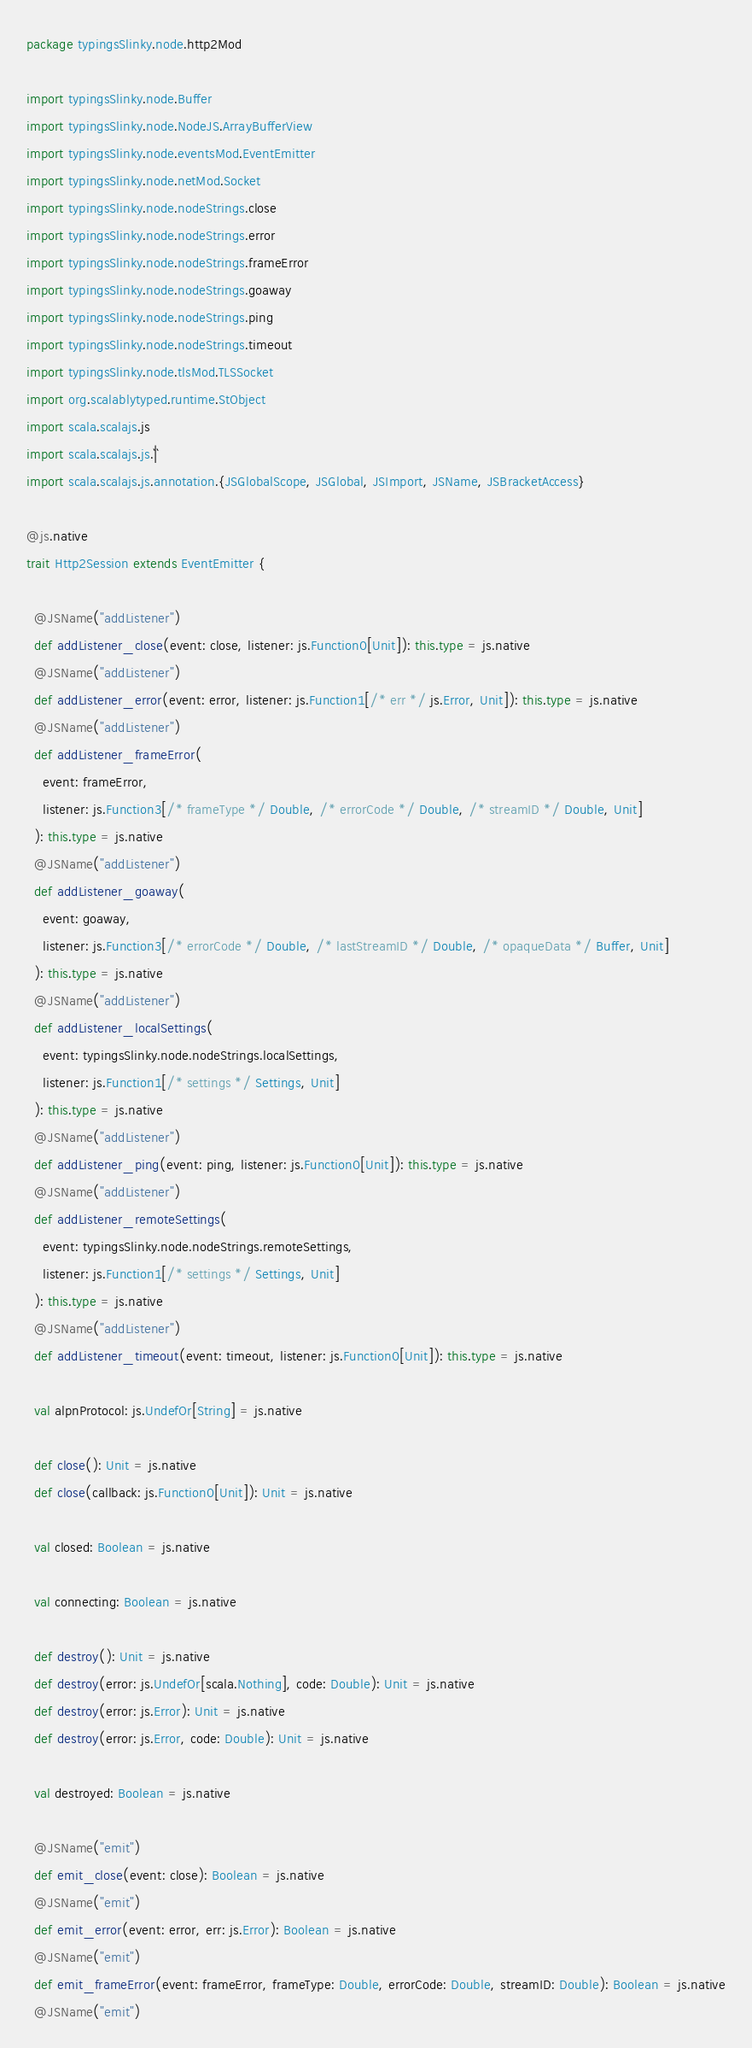Convert code to text. <code><loc_0><loc_0><loc_500><loc_500><_Scala_>package typingsSlinky.node.http2Mod

import typingsSlinky.node.Buffer
import typingsSlinky.node.NodeJS.ArrayBufferView
import typingsSlinky.node.eventsMod.EventEmitter
import typingsSlinky.node.netMod.Socket
import typingsSlinky.node.nodeStrings.close
import typingsSlinky.node.nodeStrings.error
import typingsSlinky.node.nodeStrings.frameError
import typingsSlinky.node.nodeStrings.goaway
import typingsSlinky.node.nodeStrings.ping
import typingsSlinky.node.nodeStrings.timeout
import typingsSlinky.node.tlsMod.TLSSocket
import org.scalablytyped.runtime.StObject
import scala.scalajs.js
import scala.scalajs.js.`|`
import scala.scalajs.js.annotation.{JSGlobalScope, JSGlobal, JSImport, JSName, JSBracketAccess}

@js.native
trait Http2Session extends EventEmitter {
  
  @JSName("addListener")
  def addListener_close(event: close, listener: js.Function0[Unit]): this.type = js.native
  @JSName("addListener")
  def addListener_error(event: error, listener: js.Function1[/* err */ js.Error, Unit]): this.type = js.native
  @JSName("addListener")
  def addListener_frameError(
    event: frameError,
    listener: js.Function3[/* frameType */ Double, /* errorCode */ Double, /* streamID */ Double, Unit]
  ): this.type = js.native
  @JSName("addListener")
  def addListener_goaway(
    event: goaway,
    listener: js.Function3[/* errorCode */ Double, /* lastStreamID */ Double, /* opaqueData */ Buffer, Unit]
  ): this.type = js.native
  @JSName("addListener")
  def addListener_localSettings(
    event: typingsSlinky.node.nodeStrings.localSettings,
    listener: js.Function1[/* settings */ Settings, Unit]
  ): this.type = js.native
  @JSName("addListener")
  def addListener_ping(event: ping, listener: js.Function0[Unit]): this.type = js.native
  @JSName("addListener")
  def addListener_remoteSettings(
    event: typingsSlinky.node.nodeStrings.remoteSettings,
    listener: js.Function1[/* settings */ Settings, Unit]
  ): this.type = js.native
  @JSName("addListener")
  def addListener_timeout(event: timeout, listener: js.Function0[Unit]): this.type = js.native
  
  val alpnProtocol: js.UndefOr[String] = js.native
  
  def close(): Unit = js.native
  def close(callback: js.Function0[Unit]): Unit = js.native
  
  val closed: Boolean = js.native
  
  val connecting: Boolean = js.native
  
  def destroy(): Unit = js.native
  def destroy(error: js.UndefOr[scala.Nothing], code: Double): Unit = js.native
  def destroy(error: js.Error): Unit = js.native
  def destroy(error: js.Error, code: Double): Unit = js.native
  
  val destroyed: Boolean = js.native
  
  @JSName("emit")
  def emit_close(event: close): Boolean = js.native
  @JSName("emit")
  def emit_error(event: error, err: js.Error): Boolean = js.native
  @JSName("emit")
  def emit_frameError(event: frameError, frameType: Double, errorCode: Double, streamID: Double): Boolean = js.native
  @JSName("emit")</code> 